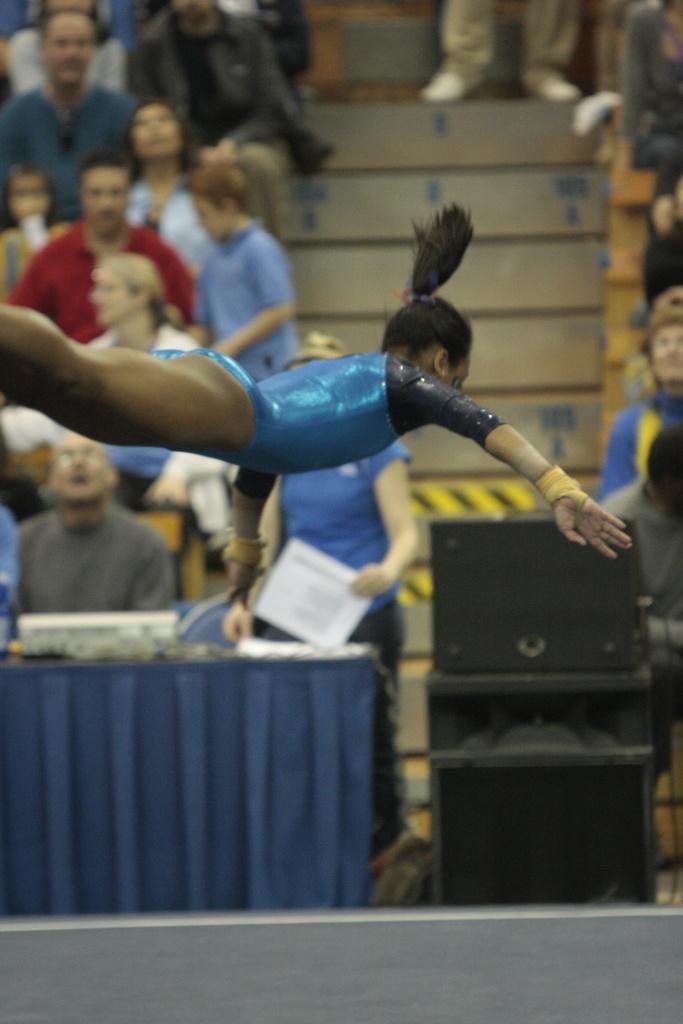Could you give a brief overview of what you see in this image? In this image I can see a woman is in the air. In the background I can see people are sitting. Here I can see steps and some other objects on the ground. 